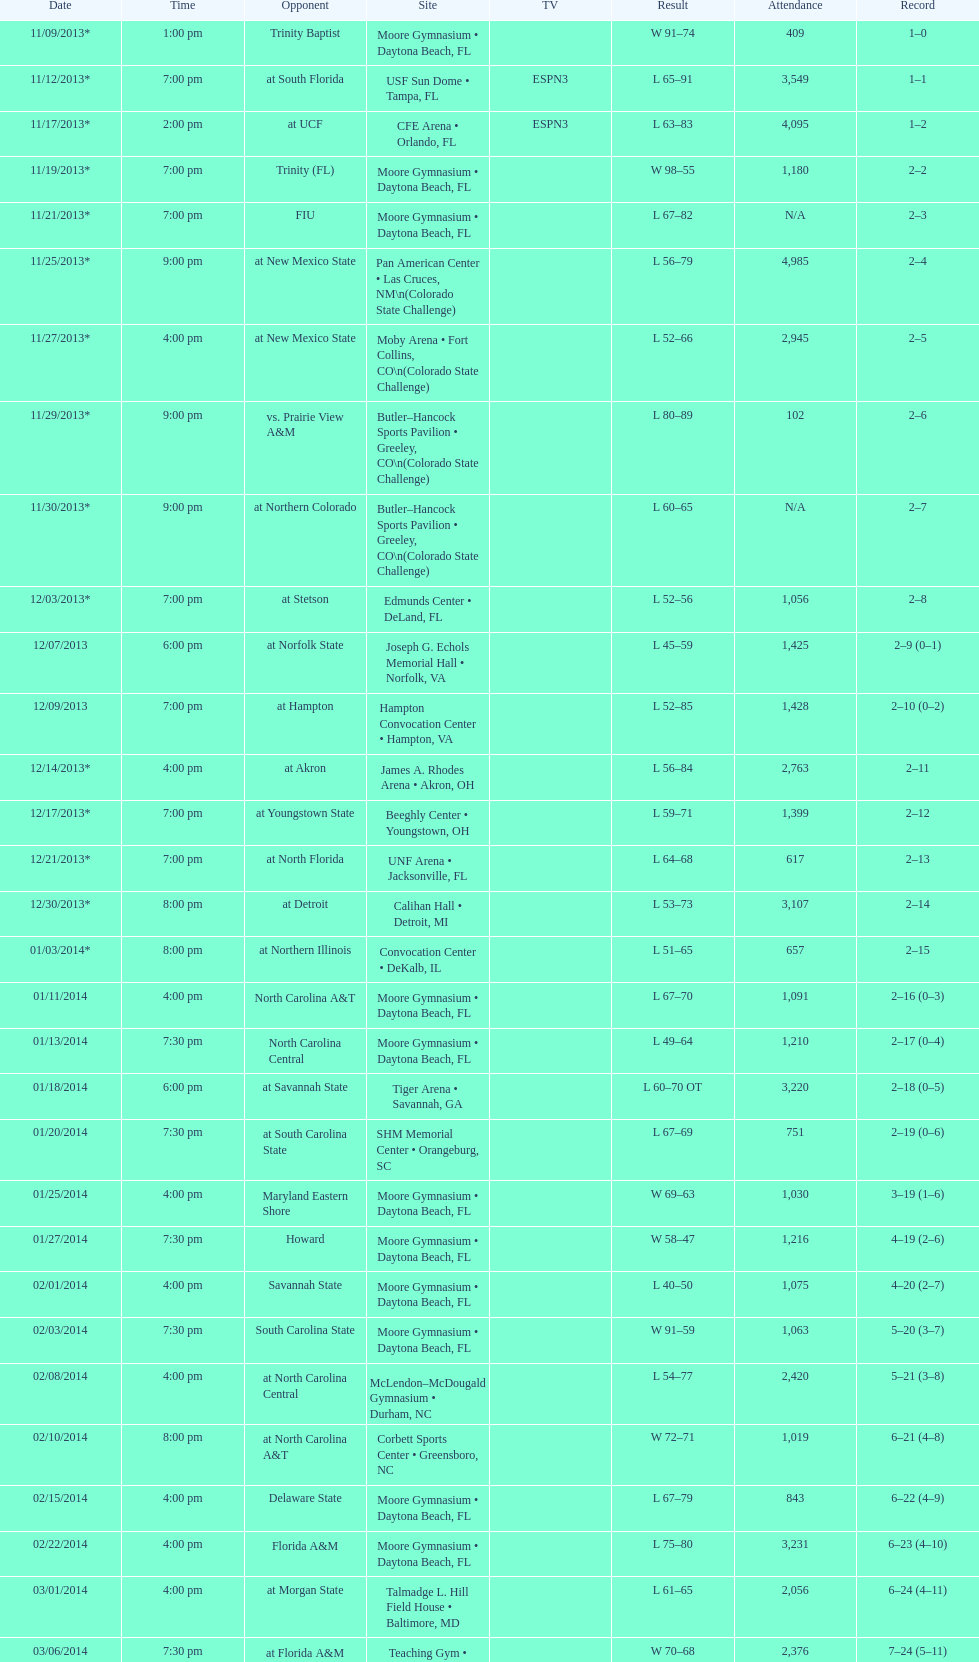Was the attendance of the game held on 11/19/2013 greater than 1,000? Yes. 